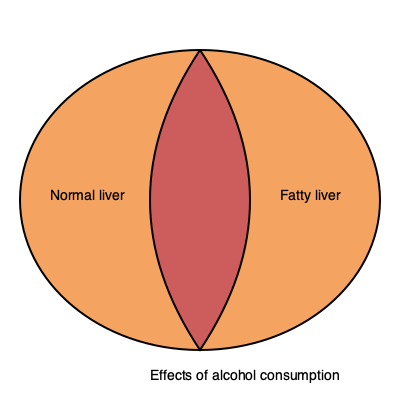In the diagram of the human liver, which area represents the part most affected by excessive alcohol consumption, and what condition does it indicate? 1. The diagram shows a cross-section of a human liver.
2. The liver is divided into two distinct areas:
   a) The left side (lighter color) represents a normal, healthy liver.
   b) The right side (darker color) represents a liver affected by alcohol consumption.
3. The darker area on the right side indicates fatty deposits in the liver tissue.
4. This condition is known as fatty liver disease or steatosis.
5. Excessive alcohol consumption leads to fat accumulation in liver cells.
6. Over time, this can progress to more severe liver damage, such as alcoholic hepatitis or cirrhosis.
7. The darker area in the diagram represents the part of the liver most affected by alcohol, showing the accumulation of fat.
Answer: Right side; fatty liver disease 